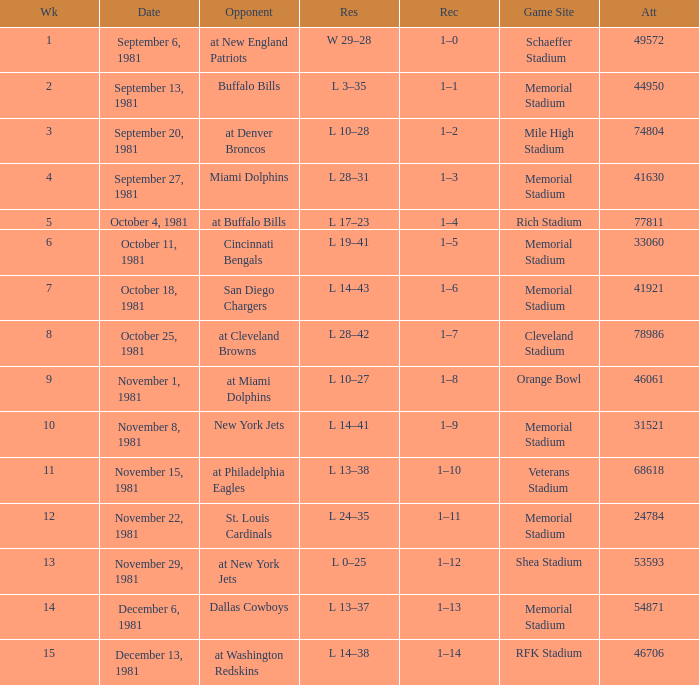When 74804 is the attendance what week is it? 3.0. 